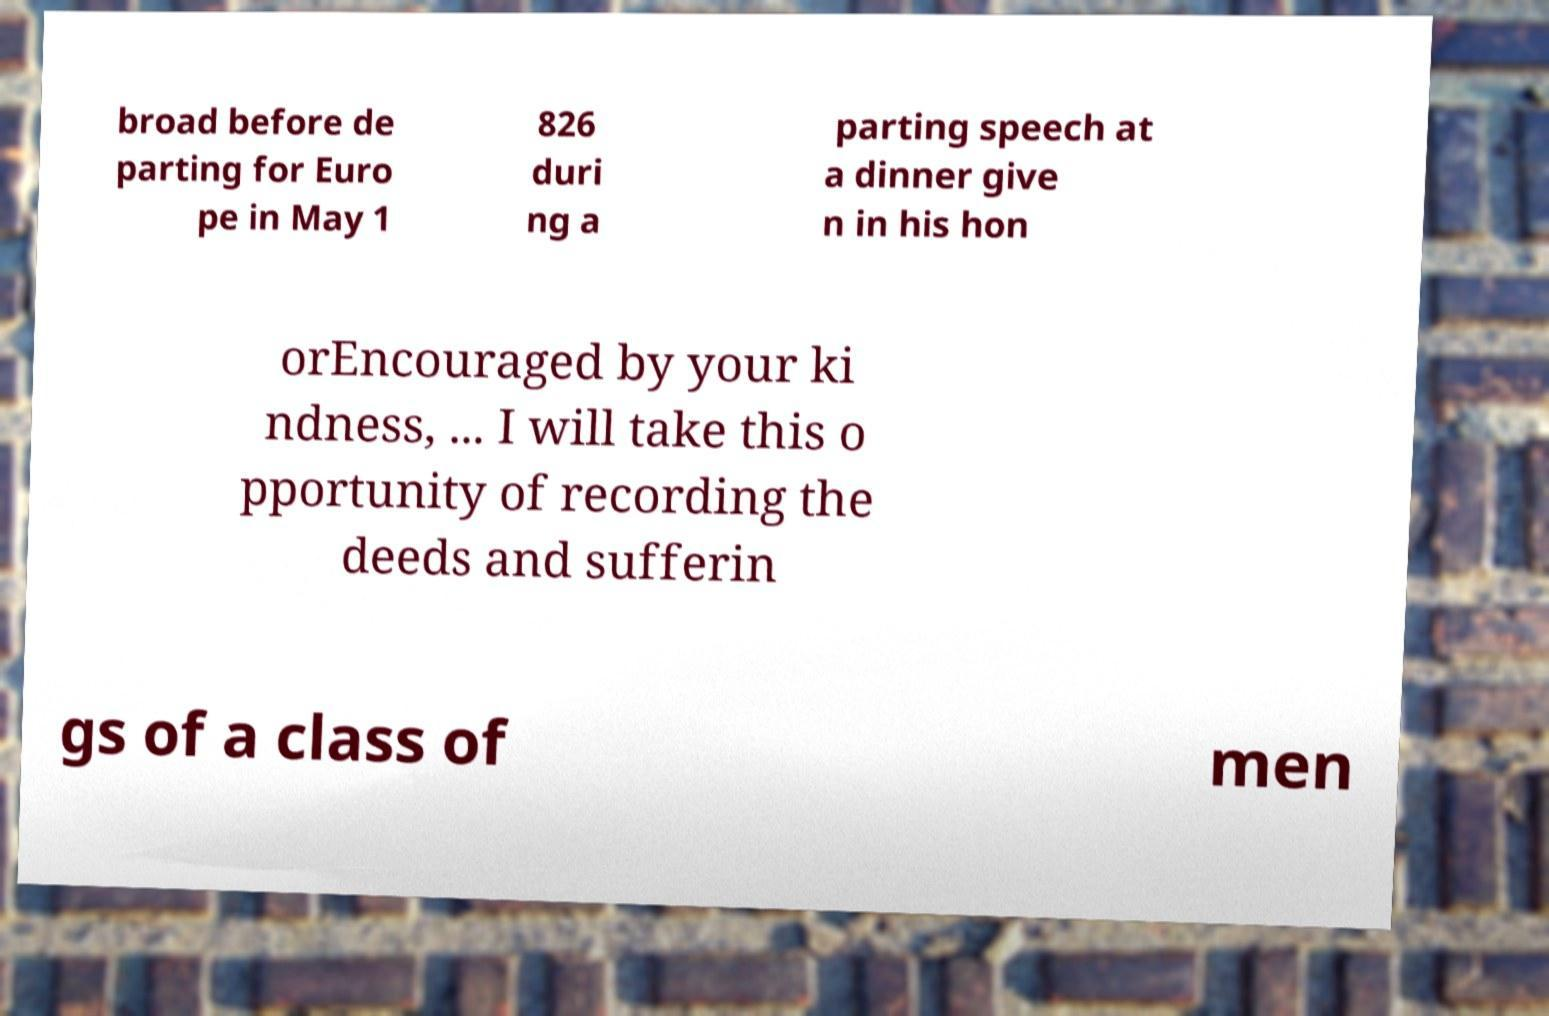There's text embedded in this image that I need extracted. Can you transcribe it verbatim? broad before de parting for Euro pe in May 1 826 duri ng a parting speech at a dinner give n in his hon orEncouraged by your ki ndness, ... I will take this o pportunity of recording the deeds and sufferin gs of a class of men 